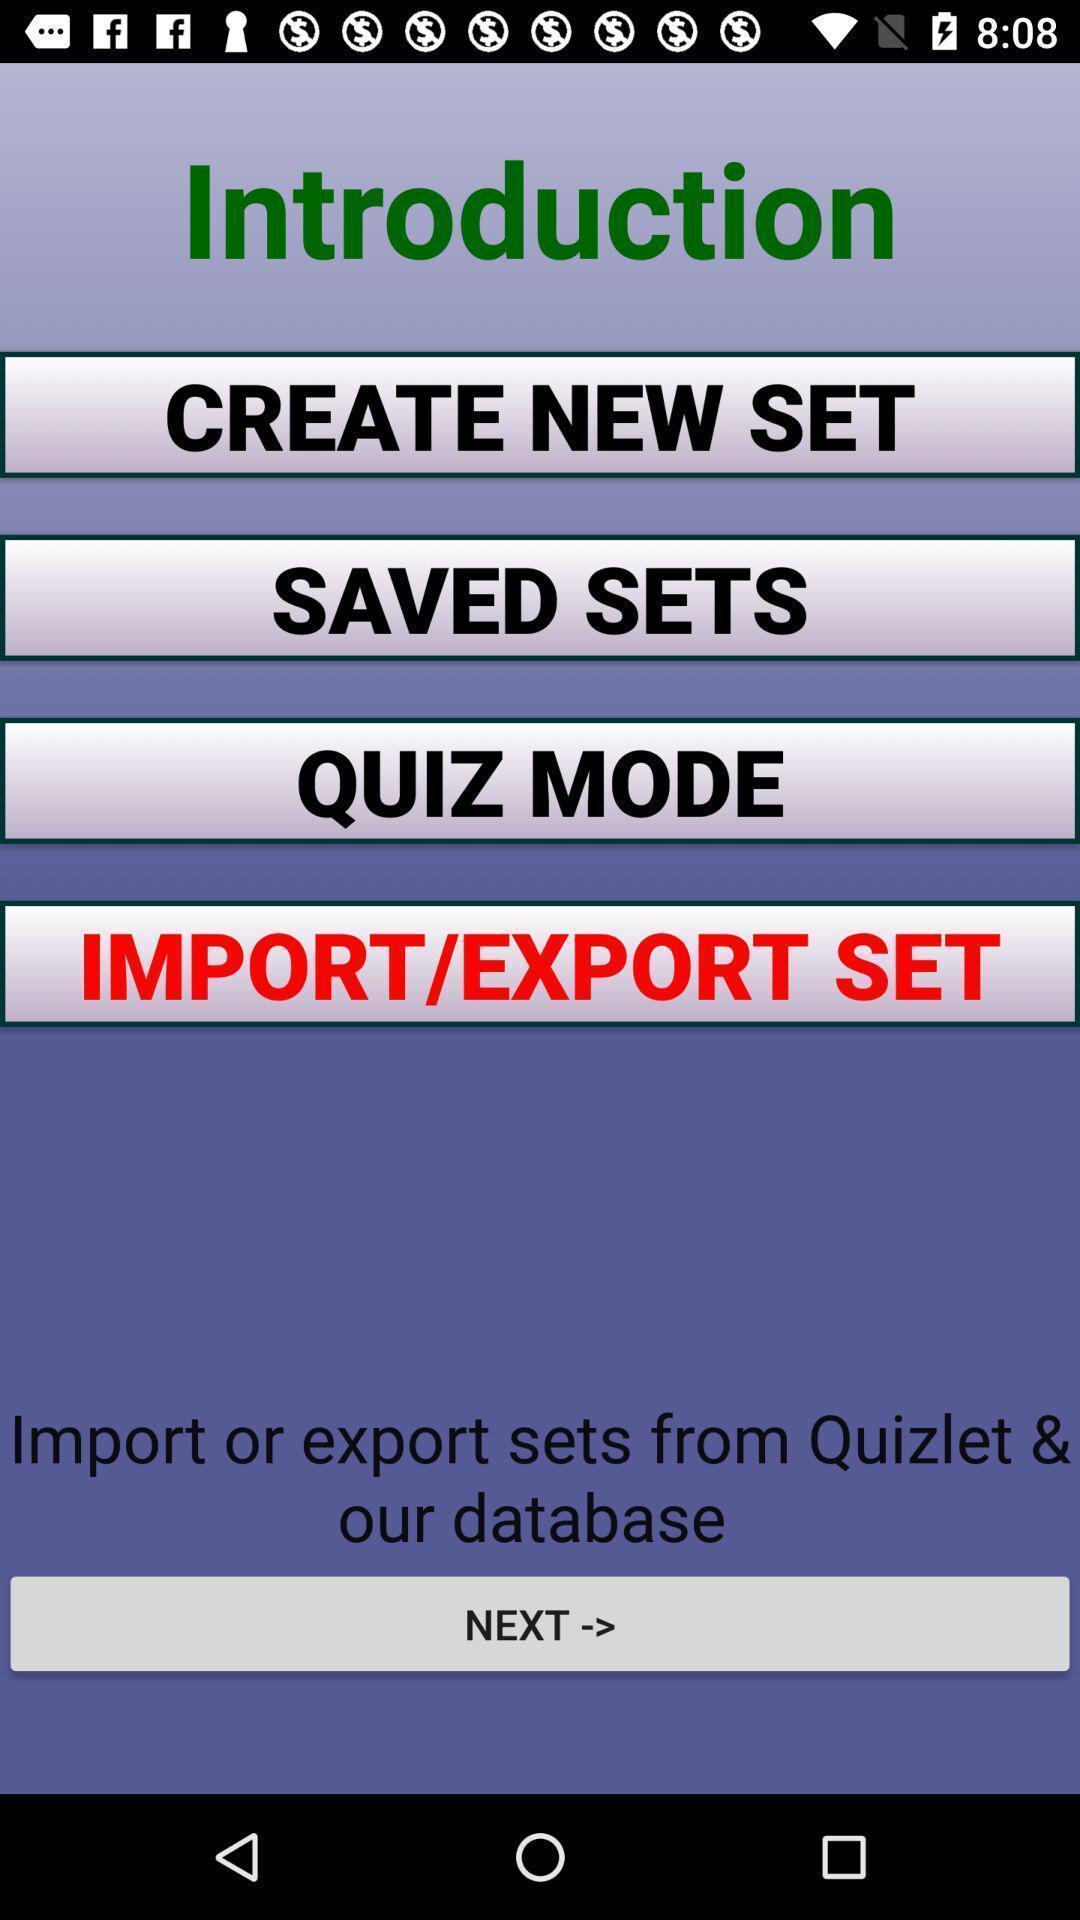Give me a summary of this screen capture. Screen displaying multiple flashcard set options in a learning application=- po. 